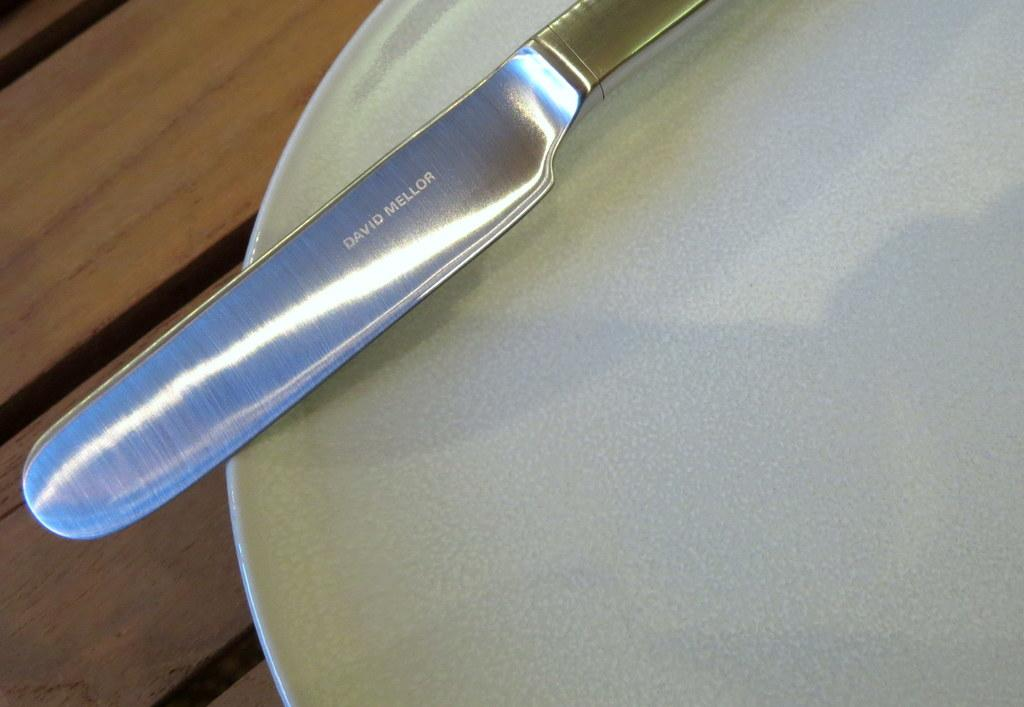What object is located on the right side of the image? There is a plate on the right side of the image. What utensil can be seen in the image? There is a butter knife in the image. What piece of furniture is at the bottom of the image? There is a table at the bottom of the image. What type of authority figure is present in the image? There is no authority figure present in the image. Can you see any evidence of a burn in the image? There is no indication of a burn in the image. 